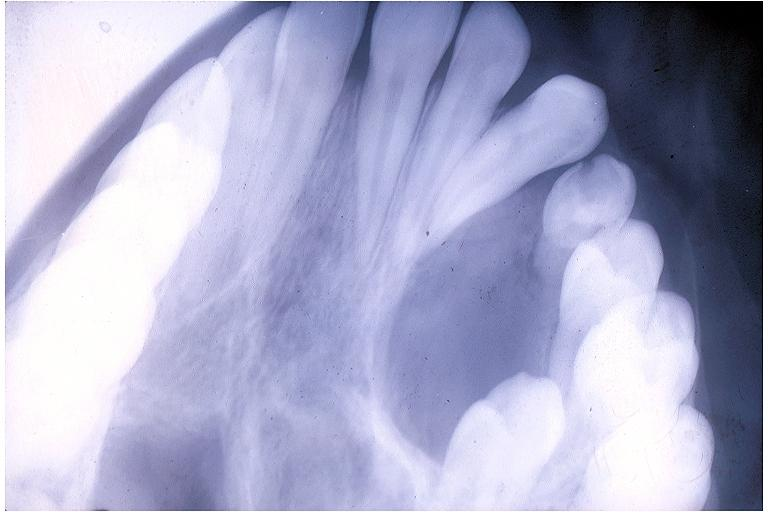what does this image show?
Answer the question using a single word or phrase. Adenomatoid odontogenic tumor 